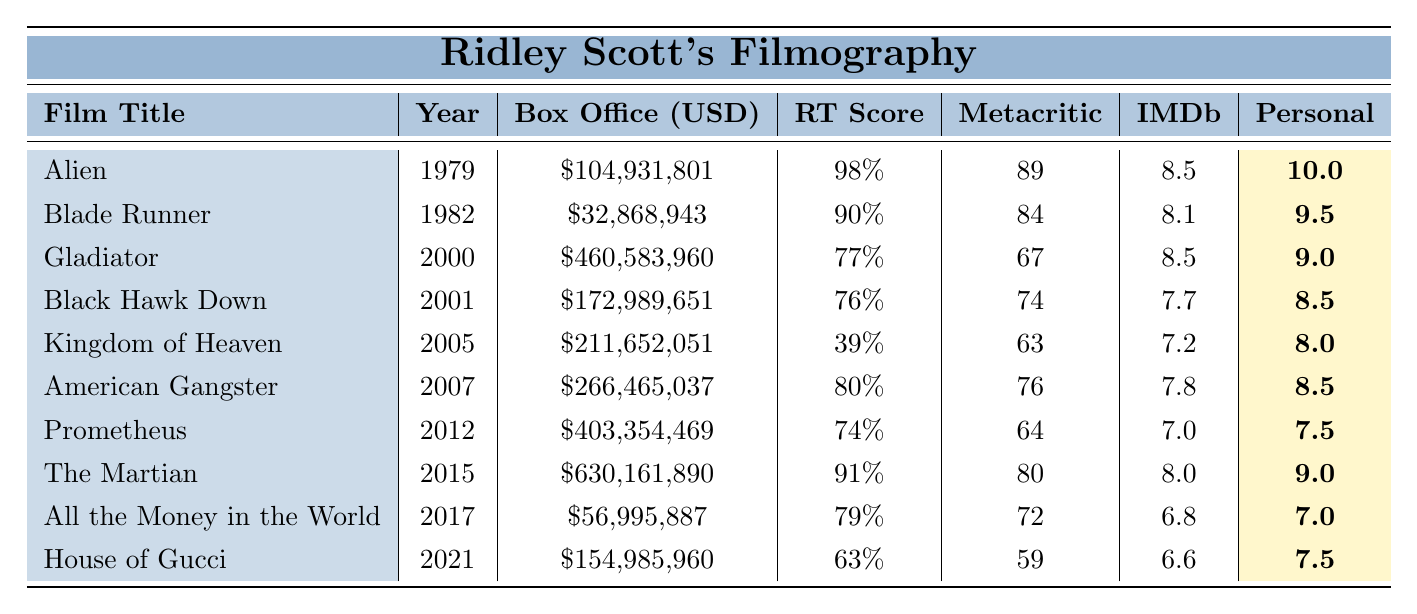What is the box office earnings of "The Martian"? The table lists the box office earnings of "The Martian" as $630,161,890.
Answer: $630,161,890 Which film has the highest Rotten Tomatoes score? The highest Rotten Tomatoes score is 98%, attributed to "Alien".
Answer: "Alien" What is the personal rating of "Gladiator"? According to the table, the personal rating for "Gladiator" is 9.0.
Answer: 9.0 How many films have a Metacritic score higher than 80? The films with a Metacritic score higher than 80 are "Alien", "Blade Runner", and "American Gangster". Thus, there are three films.
Answer: 3 What is the difference in box office earnings between "Gladiator" and "Kingdom of Heaven"? "Gladiator" earned $460,583,960 while "Kingdom of Heaven" earned $211,652,051; the difference is $460,583,960 - $211,652,051 = $248,931,909.
Answer: $248,931,909 Did "House of Gucci" earn more than "All the Money in the World"? "House of Gucci" earned $154,985,960, while "All the Money in the World" earned $56,995,887. Therefore, it is true that "House of Gucci" earned more.
Answer: Yes What is the average IMDb rating of all Ridley Scott films in the table? The IMDb ratings are 8.5, 8.1, 8.5, 7.7, 7.2, 7.8, 7.0, 8.0, 6.8, and 6.6. Adding them gives a total of 78.2, and there are 10 films, thus the average is 78.2 / 10 = 7.82.
Answer: 7.82 Which film released in 2005 has the lowest Rotten Tomatoes score? "Kingdom of Heaven", released in 2005, has a Rotten Tomatoes score of 39%, which is lower than any other film from that year.
Answer: "Kingdom of Heaven" If we consider only the films with a personal rating of 9 or higher, how many films are there? The films that have a personal rating of 9 or higher are "Alien", "Blade Runner", "Gladiator", "The Martian", and "American Gangster". Counting them gives a total of 5 films.
Answer: 5 Which film has the lowest box office earnings? "All the Money in the World" has the lowest box office earnings at $56,995,887.
Answer: "All the Money in the World" 